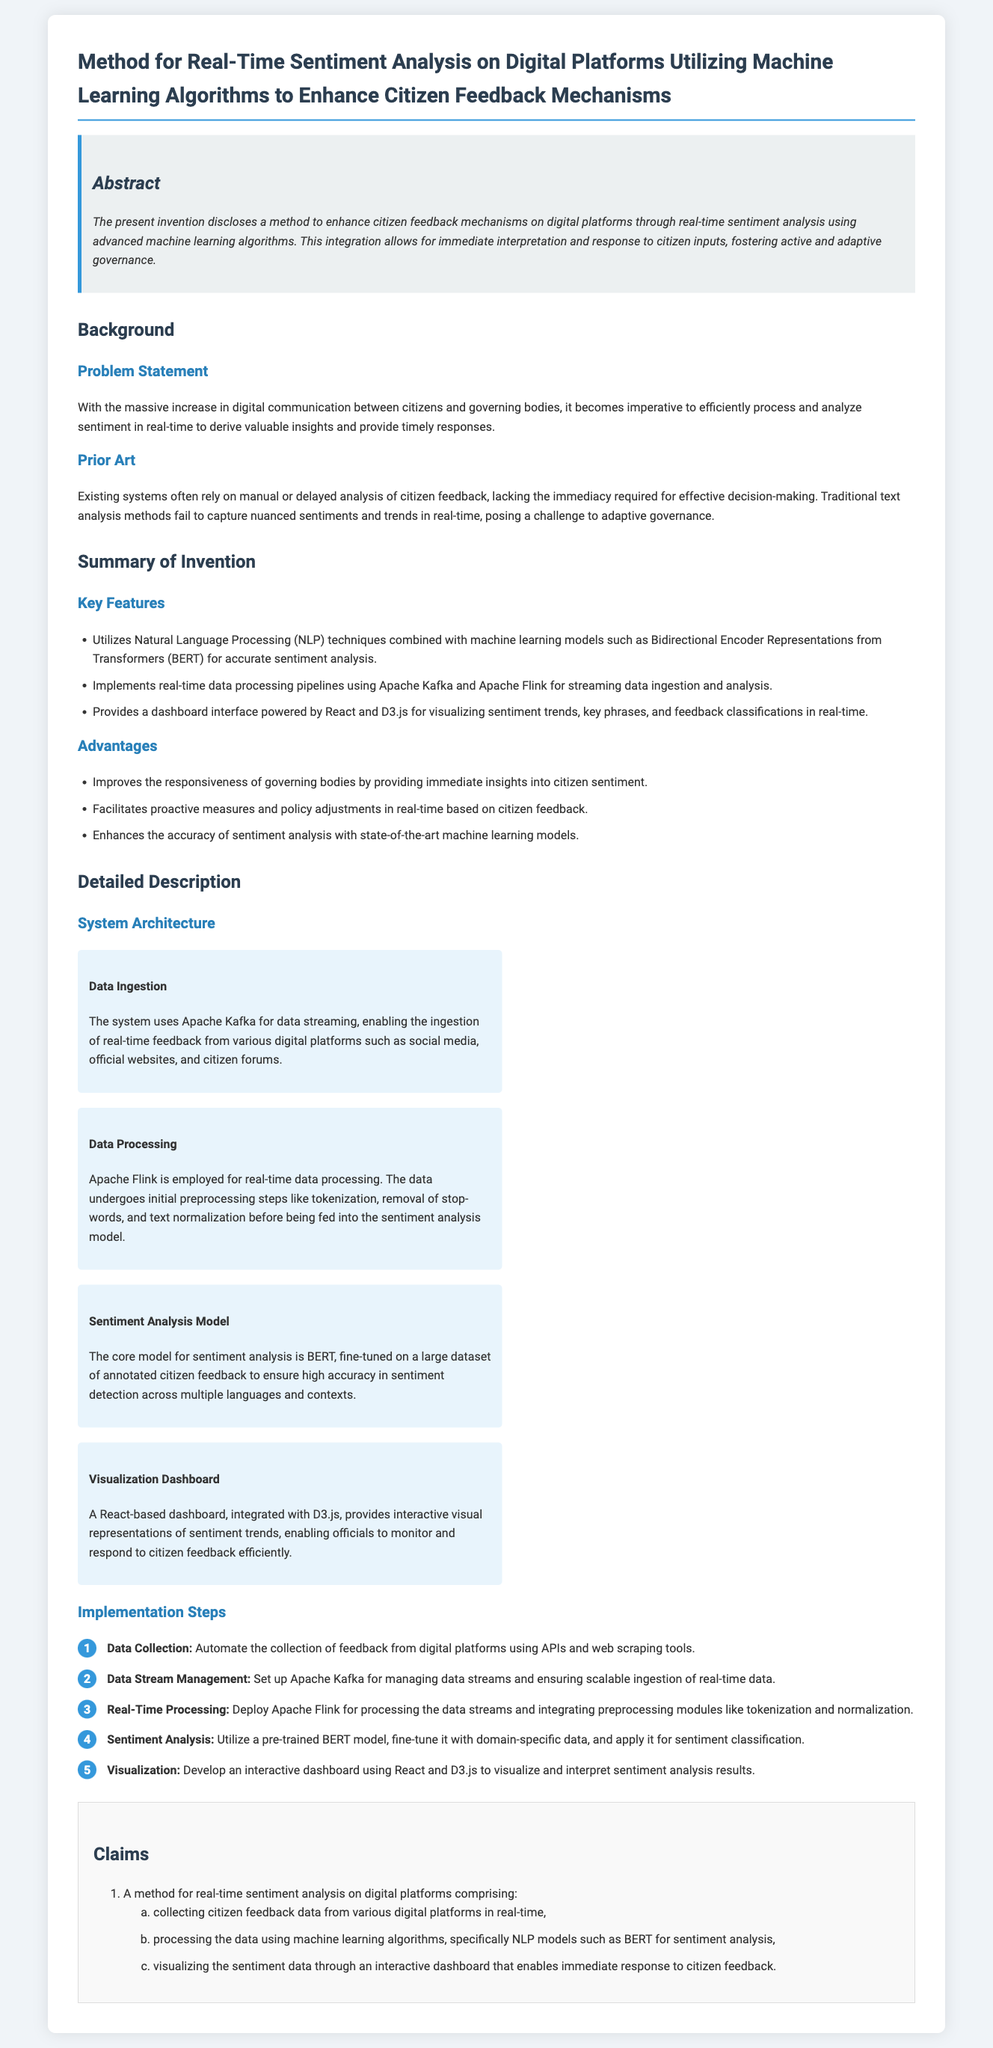What is the title of the patent application? The title of the patent application is stated prominently at the beginning of the document.
Answer: Method for Real-Time Sentiment Analysis on Digital Platforms Utilizing Machine Learning Algorithms to Enhance Citizen Feedback Mechanisms What algorithm is used for sentiment analysis? The document specifies the algorithms utilized for sentiment analysis within the system architecture section.
Answer: BERT What technology is used for data ingestion? The method for data ingestion from various platforms is mentioned in the system architecture section.
Answer: Apache Kafka What type of dashboard is developed? The document describes the visualization component as part of the system architecture.
Answer: React-based dashboard How many key features are listed in the summary of the invention? The summary section outlines specific features of the invention, and the total count is stated.
Answer: Three What does the "Claims" section detail? The claims section outlines the main inventive concepts and methods included in the application.
Answer: A method for real-time sentiment analysis Which processing tool is employed for real-time data processing? The detailed description mentions the specific tool used for processing data streams in real-time.
Answer: Apache Flink What is the primary goal of the invention? The abstract section encapsulates the main objective of the patent application.
Answer: Enhance citizen feedback mechanisms What is the advantage of using machine learning models? The invention's advantages highlight the benefits realized from employing advanced technology.
Answer: Improves the responsiveness of governing bodies 